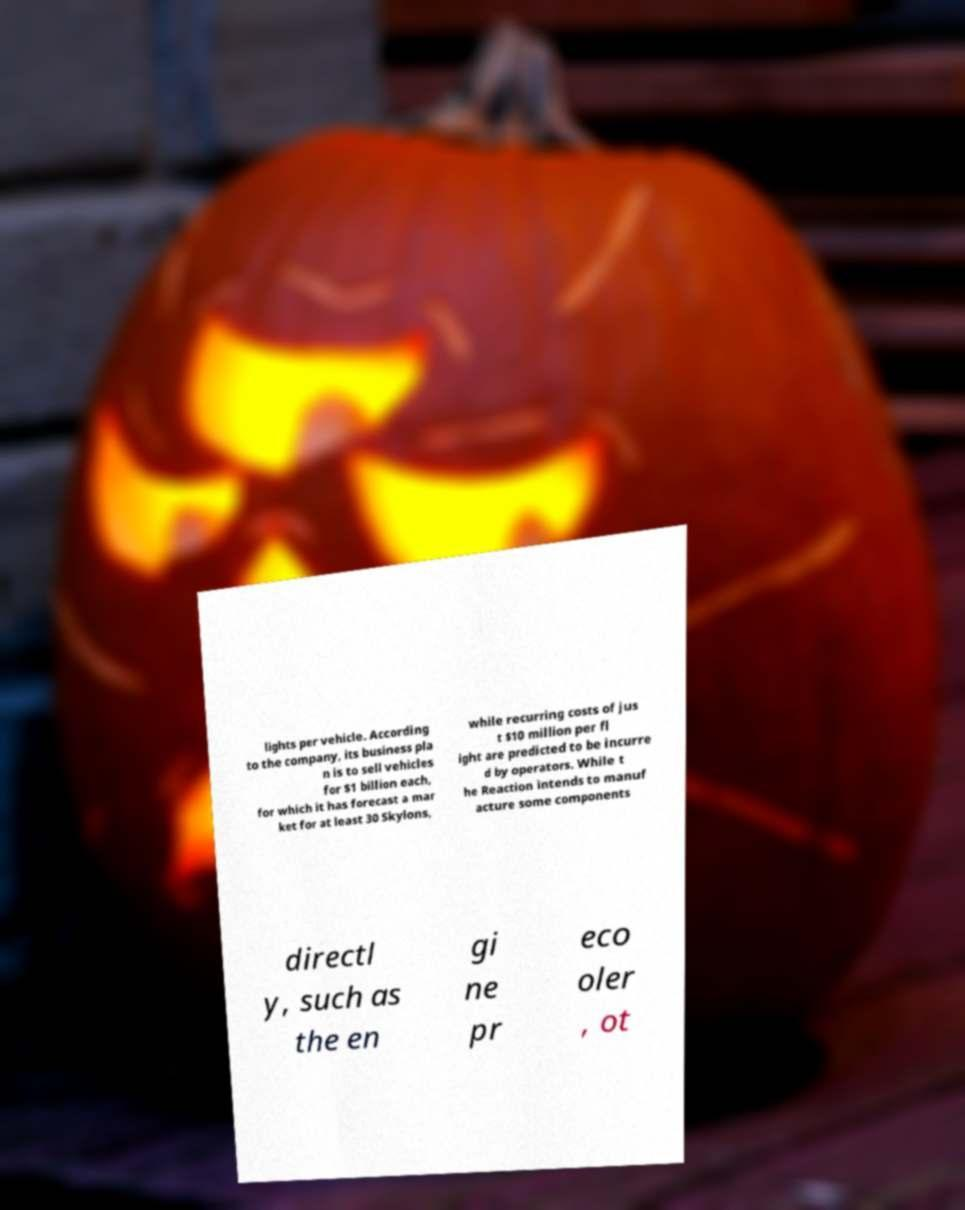There's text embedded in this image that I need extracted. Can you transcribe it verbatim? lights per vehicle. According to the company, its business pla n is to sell vehicles for $1 billion each, for which it has forecast a mar ket for at least 30 Skylons, while recurring costs of jus t $10 million per fl ight are predicted to be incurre d by operators. While t he Reaction intends to manuf acture some components directl y, such as the en gi ne pr eco oler , ot 